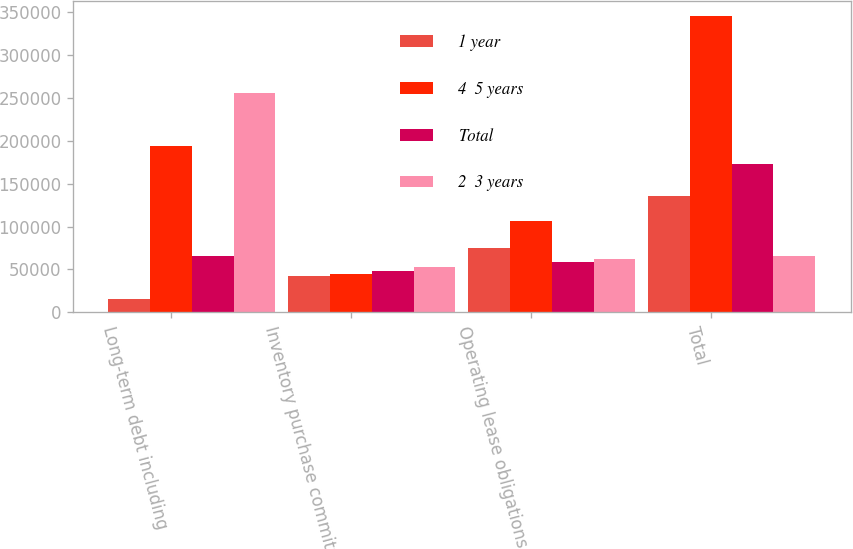Convert chart. <chart><loc_0><loc_0><loc_500><loc_500><stacked_bar_chart><ecel><fcel>Long-term debt including<fcel>Inventory purchase commitments<fcel>Operating lease obligations<fcel>Total<nl><fcel>1 year<fcel>15654<fcel>41920<fcel>75394<fcel>135380<nl><fcel>4  5 years<fcel>194421<fcel>44533<fcel>106392<fcel>346102<nl><fcel>Total<fcel>65240<fcel>48339<fcel>58866<fcel>172480<nl><fcel>2  3 years<fcel>256405<fcel>53294<fcel>61680<fcel>65240<nl></chart> 